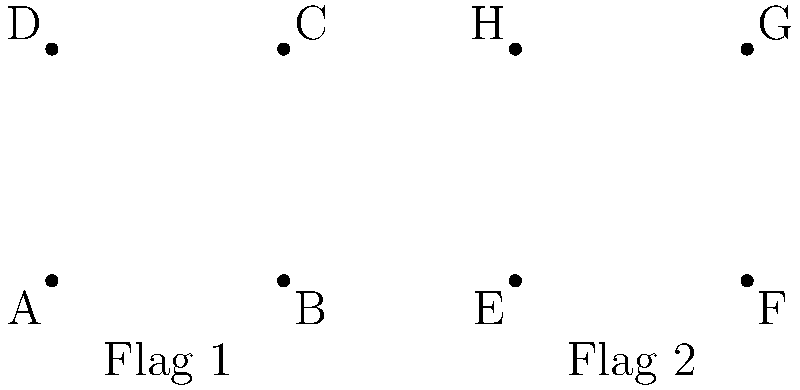In the diagram above, two national flags are represented as quadrilaterals. Flag 1 (ABCD) and Flag 2 (EFGH) have the same shape and size. If $\angle BAD = 90°$ and $AB = 50$ units, determine the number of congruence criteria that can be used to prove these flags are congruent. Let's approach this step-by-step:

1) First, we need to recall the congruence criteria for quadrilaterals:
   - CPCTC (Corresponding Parts of Congruent Triangles are Congruent)
   - SSSS (Four pairs of corresponding sides are congruent)
   - SSSF (Three pairs of corresponding sides and one pair of corresponding diagonals are congruent)
   - SAAA (One pair of corresponding sides and three pairs of corresponding angles are congruent)

2) Now, let's analyze the given information:
   - Both flags have the same shape and size, implying they are congruent.
   - Flag 1 (ABCD) has a right angle at A ($\angle BAD = 90°$).
   - AB = 50 units

3) Since the flags are congruent, we can conclude:
   - All corresponding sides are equal: AB = EF, BC = FG, CD = GH, and DA = HE
   - All corresponding angles are equal: $\angle A = \angle E$, $\angle B = \angle F$, $\angle C = \angle G$, and $\angle D = \angle H$

4) Let's check which criteria we can apply:
   - CPCTC: This can always be used once congruence is established by another method.
   - SSSS: We know all sides are equal, so this criterion can be used.
   - SSSF: We know all sides are equal, and the diagonals would also be equal. This criterion can be used.
   - SAAA: We know one side (AB = EF) and all angles are equal, so this criterion can be used.

5) Therefore, we can use 3 different criteria to prove these flags are congruent: SSSS, SSSF, and SAAA.
Answer: 3 